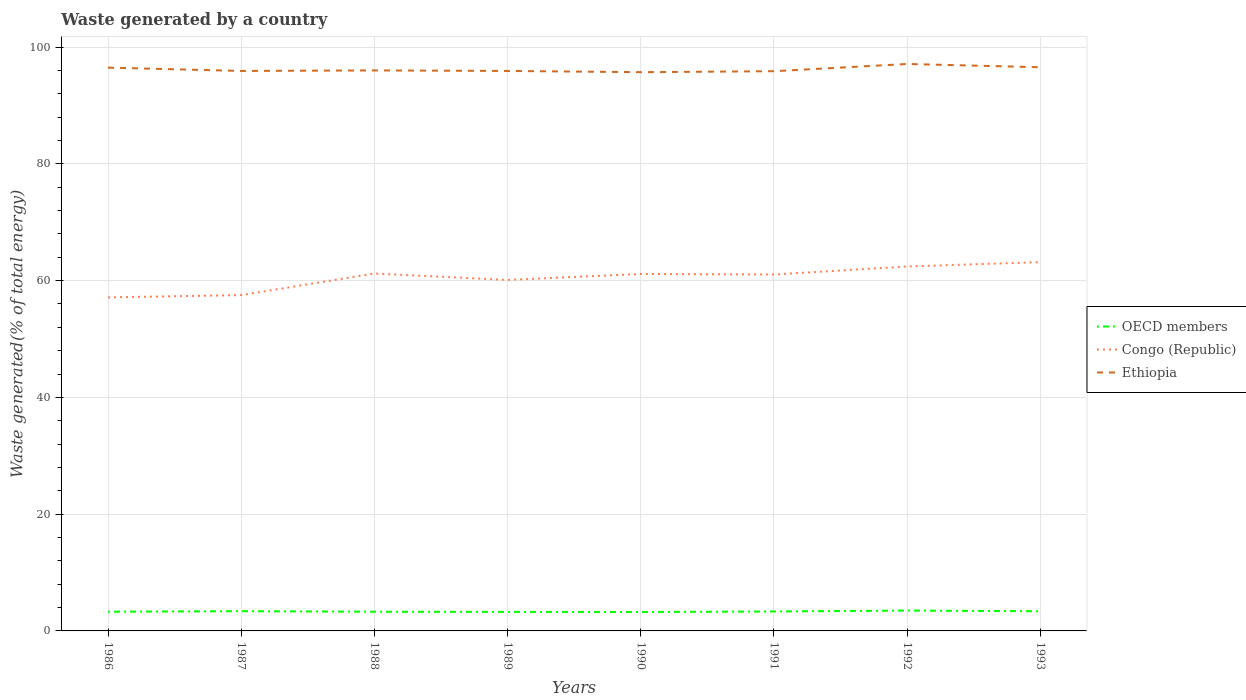Does the line corresponding to Ethiopia intersect with the line corresponding to OECD members?
Give a very brief answer. No. Across all years, what is the maximum total waste generated in Ethiopia?
Your answer should be very brief. 95.7. In which year was the total waste generated in Ethiopia maximum?
Make the answer very short. 1990. What is the total total waste generated in Ethiopia in the graph?
Your answer should be compact. 0. What is the difference between the highest and the second highest total waste generated in Ethiopia?
Your answer should be compact. 1.41. Are the values on the major ticks of Y-axis written in scientific E-notation?
Your answer should be compact. No. Does the graph contain any zero values?
Keep it short and to the point. No. Where does the legend appear in the graph?
Make the answer very short. Center right. How are the legend labels stacked?
Provide a short and direct response. Vertical. What is the title of the graph?
Ensure brevity in your answer.  Waste generated by a country. What is the label or title of the Y-axis?
Your response must be concise. Waste generated(% of total energy). What is the Waste generated(% of total energy) of OECD members in 1986?
Give a very brief answer. 3.29. What is the Waste generated(% of total energy) of Congo (Republic) in 1986?
Your response must be concise. 57.12. What is the Waste generated(% of total energy) in Ethiopia in 1986?
Keep it short and to the point. 96.48. What is the Waste generated(% of total energy) of OECD members in 1987?
Offer a terse response. 3.38. What is the Waste generated(% of total energy) in Congo (Republic) in 1987?
Offer a terse response. 57.52. What is the Waste generated(% of total energy) in Ethiopia in 1987?
Your answer should be very brief. 95.91. What is the Waste generated(% of total energy) in OECD members in 1988?
Keep it short and to the point. 3.29. What is the Waste generated(% of total energy) of Congo (Republic) in 1988?
Ensure brevity in your answer.  61.21. What is the Waste generated(% of total energy) in Ethiopia in 1988?
Your answer should be very brief. 96. What is the Waste generated(% of total energy) in OECD members in 1989?
Keep it short and to the point. 3.26. What is the Waste generated(% of total energy) in Congo (Republic) in 1989?
Offer a very short reply. 60.11. What is the Waste generated(% of total energy) of Ethiopia in 1989?
Keep it short and to the point. 95.91. What is the Waste generated(% of total energy) in OECD members in 1990?
Provide a succinct answer. 3.25. What is the Waste generated(% of total energy) in Congo (Republic) in 1990?
Give a very brief answer. 61.14. What is the Waste generated(% of total energy) of Ethiopia in 1990?
Offer a terse response. 95.7. What is the Waste generated(% of total energy) of OECD members in 1991?
Offer a very short reply. 3.33. What is the Waste generated(% of total energy) in Congo (Republic) in 1991?
Your response must be concise. 61.04. What is the Waste generated(% of total energy) in Ethiopia in 1991?
Make the answer very short. 95.86. What is the Waste generated(% of total energy) of OECD members in 1992?
Offer a very short reply. 3.48. What is the Waste generated(% of total energy) in Congo (Republic) in 1992?
Provide a succinct answer. 62.42. What is the Waste generated(% of total energy) of Ethiopia in 1992?
Offer a very short reply. 97.1. What is the Waste generated(% of total energy) of OECD members in 1993?
Your answer should be very brief. 3.37. What is the Waste generated(% of total energy) of Congo (Republic) in 1993?
Give a very brief answer. 63.16. What is the Waste generated(% of total energy) of Ethiopia in 1993?
Keep it short and to the point. 96.54. Across all years, what is the maximum Waste generated(% of total energy) in OECD members?
Make the answer very short. 3.48. Across all years, what is the maximum Waste generated(% of total energy) in Congo (Republic)?
Your answer should be very brief. 63.16. Across all years, what is the maximum Waste generated(% of total energy) in Ethiopia?
Provide a short and direct response. 97.1. Across all years, what is the minimum Waste generated(% of total energy) of OECD members?
Give a very brief answer. 3.25. Across all years, what is the minimum Waste generated(% of total energy) in Congo (Republic)?
Ensure brevity in your answer.  57.12. Across all years, what is the minimum Waste generated(% of total energy) in Ethiopia?
Offer a very short reply. 95.7. What is the total Waste generated(% of total energy) in OECD members in the graph?
Your answer should be very brief. 26.66. What is the total Waste generated(% of total energy) in Congo (Republic) in the graph?
Keep it short and to the point. 483.74. What is the total Waste generated(% of total energy) of Ethiopia in the graph?
Offer a very short reply. 769.5. What is the difference between the Waste generated(% of total energy) in OECD members in 1986 and that in 1987?
Your answer should be compact. -0.09. What is the difference between the Waste generated(% of total energy) in Congo (Republic) in 1986 and that in 1987?
Your response must be concise. -0.4. What is the difference between the Waste generated(% of total energy) in Ethiopia in 1986 and that in 1987?
Provide a succinct answer. 0.57. What is the difference between the Waste generated(% of total energy) in OECD members in 1986 and that in 1988?
Your answer should be very brief. -0. What is the difference between the Waste generated(% of total energy) in Congo (Republic) in 1986 and that in 1988?
Provide a short and direct response. -4.09. What is the difference between the Waste generated(% of total energy) of Ethiopia in 1986 and that in 1988?
Your response must be concise. 0.48. What is the difference between the Waste generated(% of total energy) of OECD members in 1986 and that in 1989?
Offer a terse response. 0.03. What is the difference between the Waste generated(% of total energy) in Congo (Republic) in 1986 and that in 1989?
Offer a very short reply. -2.99. What is the difference between the Waste generated(% of total energy) of Ethiopia in 1986 and that in 1989?
Ensure brevity in your answer.  0.57. What is the difference between the Waste generated(% of total energy) in OECD members in 1986 and that in 1990?
Provide a succinct answer. 0.05. What is the difference between the Waste generated(% of total energy) in Congo (Republic) in 1986 and that in 1990?
Make the answer very short. -4.02. What is the difference between the Waste generated(% of total energy) of Ethiopia in 1986 and that in 1990?
Provide a short and direct response. 0.78. What is the difference between the Waste generated(% of total energy) in OECD members in 1986 and that in 1991?
Offer a very short reply. -0.04. What is the difference between the Waste generated(% of total energy) in Congo (Republic) in 1986 and that in 1991?
Provide a succinct answer. -3.92. What is the difference between the Waste generated(% of total energy) of Ethiopia in 1986 and that in 1991?
Offer a terse response. 0.62. What is the difference between the Waste generated(% of total energy) of OECD members in 1986 and that in 1992?
Your response must be concise. -0.19. What is the difference between the Waste generated(% of total energy) in Congo (Republic) in 1986 and that in 1992?
Make the answer very short. -5.29. What is the difference between the Waste generated(% of total energy) of Ethiopia in 1986 and that in 1992?
Make the answer very short. -0.62. What is the difference between the Waste generated(% of total energy) of OECD members in 1986 and that in 1993?
Your response must be concise. -0.08. What is the difference between the Waste generated(% of total energy) of Congo (Republic) in 1986 and that in 1993?
Give a very brief answer. -6.04. What is the difference between the Waste generated(% of total energy) of Ethiopia in 1986 and that in 1993?
Offer a terse response. -0.06. What is the difference between the Waste generated(% of total energy) of OECD members in 1987 and that in 1988?
Ensure brevity in your answer.  0.09. What is the difference between the Waste generated(% of total energy) in Congo (Republic) in 1987 and that in 1988?
Keep it short and to the point. -3.7. What is the difference between the Waste generated(% of total energy) of Ethiopia in 1987 and that in 1988?
Your response must be concise. -0.09. What is the difference between the Waste generated(% of total energy) in OECD members in 1987 and that in 1989?
Your answer should be very brief. 0.12. What is the difference between the Waste generated(% of total energy) of Congo (Republic) in 1987 and that in 1989?
Keep it short and to the point. -2.59. What is the difference between the Waste generated(% of total energy) of OECD members in 1987 and that in 1990?
Offer a very short reply. 0.13. What is the difference between the Waste generated(% of total energy) in Congo (Republic) in 1987 and that in 1990?
Keep it short and to the point. -3.62. What is the difference between the Waste generated(% of total energy) of Ethiopia in 1987 and that in 1990?
Your answer should be compact. 0.21. What is the difference between the Waste generated(% of total energy) in OECD members in 1987 and that in 1991?
Offer a very short reply. 0.05. What is the difference between the Waste generated(% of total energy) of Congo (Republic) in 1987 and that in 1991?
Offer a terse response. -3.52. What is the difference between the Waste generated(% of total energy) in Ethiopia in 1987 and that in 1991?
Offer a terse response. 0.05. What is the difference between the Waste generated(% of total energy) of OECD members in 1987 and that in 1992?
Your answer should be very brief. -0.11. What is the difference between the Waste generated(% of total energy) in Congo (Republic) in 1987 and that in 1992?
Your response must be concise. -4.9. What is the difference between the Waste generated(% of total energy) of Ethiopia in 1987 and that in 1992?
Your response must be concise. -1.19. What is the difference between the Waste generated(% of total energy) in OECD members in 1987 and that in 1993?
Your response must be concise. 0.01. What is the difference between the Waste generated(% of total energy) of Congo (Republic) in 1987 and that in 1993?
Provide a short and direct response. -5.65. What is the difference between the Waste generated(% of total energy) in Ethiopia in 1987 and that in 1993?
Offer a very short reply. -0.63. What is the difference between the Waste generated(% of total energy) of OECD members in 1988 and that in 1989?
Ensure brevity in your answer.  0.03. What is the difference between the Waste generated(% of total energy) in Congo (Republic) in 1988 and that in 1989?
Keep it short and to the point. 1.1. What is the difference between the Waste generated(% of total energy) in Ethiopia in 1988 and that in 1989?
Your answer should be compact. 0.09. What is the difference between the Waste generated(% of total energy) of OECD members in 1988 and that in 1990?
Your answer should be very brief. 0.05. What is the difference between the Waste generated(% of total energy) of Congo (Republic) in 1988 and that in 1990?
Offer a terse response. 0.07. What is the difference between the Waste generated(% of total energy) in Ethiopia in 1988 and that in 1990?
Offer a very short reply. 0.3. What is the difference between the Waste generated(% of total energy) of OECD members in 1988 and that in 1991?
Ensure brevity in your answer.  -0.04. What is the difference between the Waste generated(% of total energy) of Congo (Republic) in 1988 and that in 1991?
Give a very brief answer. 0.17. What is the difference between the Waste generated(% of total energy) of Ethiopia in 1988 and that in 1991?
Your answer should be very brief. 0.13. What is the difference between the Waste generated(% of total energy) of OECD members in 1988 and that in 1992?
Your answer should be compact. -0.19. What is the difference between the Waste generated(% of total energy) of Congo (Republic) in 1988 and that in 1992?
Your response must be concise. -1.2. What is the difference between the Waste generated(% of total energy) in Ethiopia in 1988 and that in 1992?
Provide a succinct answer. -1.1. What is the difference between the Waste generated(% of total energy) of OECD members in 1988 and that in 1993?
Your answer should be very brief. -0.08. What is the difference between the Waste generated(% of total energy) of Congo (Republic) in 1988 and that in 1993?
Your answer should be compact. -1.95. What is the difference between the Waste generated(% of total energy) of Ethiopia in 1988 and that in 1993?
Offer a very short reply. -0.54. What is the difference between the Waste generated(% of total energy) in OECD members in 1989 and that in 1990?
Give a very brief answer. 0.02. What is the difference between the Waste generated(% of total energy) in Congo (Republic) in 1989 and that in 1990?
Provide a short and direct response. -1.03. What is the difference between the Waste generated(% of total energy) of Ethiopia in 1989 and that in 1990?
Keep it short and to the point. 0.21. What is the difference between the Waste generated(% of total energy) in OECD members in 1989 and that in 1991?
Your answer should be compact. -0.07. What is the difference between the Waste generated(% of total energy) in Congo (Republic) in 1989 and that in 1991?
Provide a short and direct response. -0.93. What is the difference between the Waste generated(% of total energy) in Ethiopia in 1989 and that in 1991?
Provide a short and direct response. 0.04. What is the difference between the Waste generated(% of total energy) of OECD members in 1989 and that in 1992?
Provide a short and direct response. -0.22. What is the difference between the Waste generated(% of total energy) of Congo (Republic) in 1989 and that in 1992?
Give a very brief answer. -2.31. What is the difference between the Waste generated(% of total energy) of Ethiopia in 1989 and that in 1992?
Provide a succinct answer. -1.19. What is the difference between the Waste generated(% of total energy) of OECD members in 1989 and that in 1993?
Keep it short and to the point. -0.11. What is the difference between the Waste generated(% of total energy) of Congo (Republic) in 1989 and that in 1993?
Make the answer very short. -3.05. What is the difference between the Waste generated(% of total energy) in Ethiopia in 1989 and that in 1993?
Provide a short and direct response. -0.63. What is the difference between the Waste generated(% of total energy) of OECD members in 1990 and that in 1991?
Provide a short and direct response. -0.08. What is the difference between the Waste generated(% of total energy) in Congo (Republic) in 1990 and that in 1991?
Provide a short and direct response. 0.1. What is the difference between the Waste generated(% of total energy) of Ethiopia in 1990 and that in 1991?
Your answer should be very brief. -0.17. What is the difference between the Waste generated(% of total energy) in OECD members in 1990 and that in 1992?
Provide a short and direct response. -0.24. What is the difference between the Waste generated(% of total energy) of Congo (Republic) in 1990 and that in 1992?
Keep it short and to the point. -1.28. What is the difference between the Waste generated(% of total energy) in Ethiopia in 1990 and that in 1992?
Make the answer very short. -1.41. What is the difference between the Waste generated(% of total energy) of OECD members in 1990 and that in 1993?
Provide a succinct answer. -0.12. What is the difference between the Waste generated(% of total energy) of Congo (Republic) in 1990 and that in 1993?
Your response must be concise. -2.02. What is the difference between the Waste generated(% of total energy) in Ethiopia in 1990 and that in 1993?
Your response must be concise. -0.84. What is the difference between the Waste generated(% of total energy) of OECD members in 1991 and that in 1992?
Your answer should be very brief. -0.15. What is the difference between the Waste generated(% of total energy) of Congo (Republic) in 1991 and that in 1992?
Your answer should be very brief. -1.38. What is the difference between the Waste generated(% of total energy) in Ethiopia in 1991 and that in 1992?
Ensure brevity in your answer.  -1.24. What is the difference between the Waste generated(% of total energy) in OECD members in 1991 and that in 1993?
Provide a succinct answer. -0.04. What is the difference between the Waste generated(% of total energy) of Congo (Republic) in 1991 and that in 1993?
Ensure brevity in your answer.  -2.12. What is the difference between the Waste generated(% of total energy) of Ethiopia in 1991 and that in 1993?
Make the answer very short. -0.68. What is the difference between the Waste generated(% of total energy) of OECD members in 1992 and that in 1993?
Keep it short and to the point. 0.12. What is the difference between the Waste generated(% of total energy) in Congo (Republic) in 1992 and that in 1993?
Provide a short and direct response. -0.75. What is the difference between the Waste generated(% of total energy) in Ethiopia in 1992 and that in 1993?
Your answer should be compact. 0.56. What is the difference between the Waste generated(% of total energy) in OECD members in 1986 and the Waste generated(% of total energy) in Congo (Republic) in 1987?
Give a very brief answer. -54.23. What is the difference between the Waste generated(% of total energy) of OECD members in 1986 and the Waste generated(% of total energy) of Ethiopia in 1987?
Offer a terse response. -92.62. What is the difference between the Waste generated(% of total energy) of Congo (Republic) in 1986 and the Waste generated(% of total energy) of Ethiopia in 1987?
Provide a succinct answer. -38.79. What is the difference between the Waste generated(% of total energy) of OECD members in 1986 and the Waste generated(% of total energy) of Congo (Republic) in 1988?
Ensure brevity in your answer.  -57.92. What is the difference between the Waste generated(% of total energy) in OECD members in 1986 and the Waste generated(% of total energy) in Ethiopia in 1988?
Keep it short and to the point. -92.71. What is the difference between the Waste generated(% of total energy) of Congo (Republic) in 1986 and the Waste generated(% of total energy) of Ethiopia in 1988?
Ensure brevity in your answer.  -38.88. What is the difference between the Waste generated(% of total energy) of OECD members in 1986 and the Waste generated(% of total energy) of Congo (Republic) in 1989?
Offer a terse response. -56.82. What is the difference between the Waste generated(% of total energy) of OECD members in 1986 and the Waste generated(% of total energy) of Ethiopia in 1989?
Offer a terse response. -92.62. What is the difference between the Waste generated(% of total energy) of Congo (Republic) in 1986 and the Waste generated(% of total energy) of Ethiopia in 1989?
Give a very brief answer. -38.79. What is the difference between the Waste generated(% of total energy) of OECD members in 1986 and the Waste generated(% of total energy) of Congo (Republic) in 1990?
Offer a very short reply. -57.85. What is the difference between the Waste generated(% of total energy) of OECD members in 1986 and the Waste generated(% of total energy) of Ethiopia in 1990?
Your response must be concise. -92.4. What is the difference between the Waste generated(% of total energy) in Congo (Republic) in 1986 and the Waste generated(% of total energy) in Ethiopia in 1990?
Your answer should be compact. -38.57. What is the difference between the Waste generated(% of total energy) in OECD members in 1986 and the Waste generated(% of total energy) in Congo (Republic) in 1991?
Keep it short and to the point. -57.75. What is the difference between the Waste generated(% of total energy) of OECD members in 1986 and the Waste generated(% of total energy) of Ethiopia in 1991?
Your response must be concise. -92.57. What is the difference between the Waste generated(% of total energy) in Congo (Republic) in 1986 and the Waste generated(% of total energy) in Ethiopia in 1991?
Provide a succinct answer. -38.74. What is the difference between the Waste generated(% of total energy) of OECD members in 1986 and the Waste generated(% of total energy) of Congo (Republic) in 1992?
Provide a short and direct response. -59.13. What is the difference between the Waste generated(% of total energy) in OECD members in 1986 and the Waste generated(% of total energy) in Ethiopia in 1992?
Provide a succinct answer. -93.81. What is the difference between the Waste generated(% of total energy) of Congo (Republic) in 1986 and the Waste generated(% of total energy) of Ethiopia in 1992?
Provide a succinct answer. -39.98. What is the difference between the Waste generated(% of total energy) of OECD members in 1986 and the Waste generated(% of total energy) of Congo (Republic) in 1993?
Provide a short and direct response. -59.87. What is the difference between the Waste generated(% of total energy) in OECD members in 1986 and the Waste generated(% of total energy) in Ethiopia in 1993?
Your answer should be very brief. -93.25. What is the difference between the Waste generated(% of total energy) of Congo (Republic) in 1986 and the Waste generated(% of total energy) of Ethiopia in 1993?
Ensure brevity in your answer.  -39.42. What is the difference between the Waste generated(% of total energy) of OECD members in 1987 and the Waste generated(% of total energy) of Congo (Republic) in 1988?
Your response must be concise. -57.84. What is the difference between the Waste generated(% of total energy) in OECD members in 1987 and the Waste generated(% of total energy) in Ethiopia in 1988?
Keep it short and to the point. -92.62. What is the difference between the Waste generated(% of total energy) in Congo (Republic) in 1987 and the Waste generated(% of total energy) in Ethiopia in 1988?
Offer a very short reply. -38.48. What is the difference between the Waste generated(% of total energy) in OECD members in 1987 and the Waste generated(% of total energy) in Congo (Republic) in 1989?
Make the answer very short. -56.73. What is the difference between the Waste generated(% of total energy) in OECD members in 1987 and the Waste generated(% of total energy) in Ethiopia in 1989?
Give a very brief answer. -92.53. What is the difference between the Waste generated(% of total energy) in Congo (Republic) in 1987 and the Waste generated(% of total energy) in Ethiopia in 1989?
Provide a succinct answer. -38.39. What is the difference between the Waste generated(% of total energy) of OECD members in 1987 and the Waste generated(% of total energy) of Congo (Republic) in 1990?
Keep it short and to the point. -57.76. What is the difference between the Waste generated(% of total energy) of OECD members in 1987 and the Waste generated(% of total energy) of Ethiopia in 1990?
Give a very brief answer. -92.32. What is the difference between the Waste generated(% of total energy) of Congo (Republic) in 1987 and the Waste generated(% of total energy) of Ethiopia in 1990?
Your response must be concise. -38.18. What is the difference between the Waste generated(% of total energy) in OECD members in 1987 and the Waste generated(% of total energy) in Congo (Republic) in 1991?
Provide a short and direct response. -57.66. What is the difference between the Waste generated(% of total energy) of OECD members in 1987 and the Waste generated(% of total energy) of Ethiopia in 1991?
Your answer should be very brief. -92.48. What is the difference between the Waste generated(% of total energy) of Congo (Republic) in 1987 and the Waste generated(% of total energy) of Ethiopia in 1991?
Give a very brief answer. -38.35. What is the difference between the Waste generated(% of total energy) of OECD members in 1987 and the Waste generated(% of total energy) of Congo (Republic) in 1992?
Your response must be concise. -59.04. What is the difference between the Waste generated(% of total energy) in OECD members in 1987 and the Waste generated(% of total energy) in Ethiopia in 1992?
Provide a short and direct response. -93.72. What is the difference between the Waste generated(% of total energy) in Congo (Republic) in 1987 and the Waste generated(% of total energy) in Ethiopia in 1992?
Provide a succinct answer. -39.58. What is the difference between the Waste generated(% of total energy) of OECD members in 1987 and the Waste generated(% of total energy) of Congo (Republic) in 1993?
Offer a terse response. -59.79. What is the difference between the Waste generated(% of total energy) of OECD members in 1987 and the Waste generated(% of total energy) of Ethiopia in 1993?
Offer a very short reply. -93.16. What is the difference between the Waste generated(% of total energy) of Congo (Republic) in 1987 and the Waste generated(% of total energy) of Ethiopia in 1993?
Your answer should be compact. -39.02. What is the difference between the Waste generated(% of total energy) of OECD members in 1988 and the Waste generated(% of total energy) of Congo (Republic) in 1989?
Make the answer very short. -56.82. What is the difference between the Waste generated(% of total energy) of OECD members in 1988 and the Waste generated(% of total energy) of Ethiopia in 1989?
Keep it short and to the point. -92.62. What is the difference between the Waste generated(% of total energy) in Congo (Republic) in 1988 and the Waste generated(% of total energy) in Ethiopia in 1989?
Your response must be concise. -34.69. What is the difference between the Waste generated(% of total energy) of OECD members in 1988 and the Waste generated(% of total energy) of Congo (Republic) in 1990?
Offer a very short reply. -57.85. What is the difference between the Waste generated(% of total energy) in OECD members in 1988 and the Waste generated(% of total energy) in Ethiopia in 1990?
Your response must be concise. -92.4. What is the difference between the Waste generated(% of total energy) in Congo (Republic) in 1988 and the Waste generated(% of total energy) in Ethiopia in 1990?
Provide a succinct answer. -34.48. What is the difference between the Waste generated(% of total energy) in OECD members in 1988 and the Waste generated(% of total energy) in Congo (Republic) in 1991?
Make the answer very short. -57.75. What is the difference between the Waste generated(% of total energy) of OECD members in 1988 and the Waste generated(% of total energy) of Ethiopia in 1991?
Provide a short and direct response. -92.57. What is the difference between the Waste generated(% of total energy) in Congo (Republic) in 1988 and the Waste generated(% of total energy) in Ethiopia in 1991?
Offer a very short reply. -34.65. What is the difference between the Waste generated(% of total energy) in OECD members in 1988 and the Waste generated(% of total energy) in Congo (Republic) in 1992?
Your answer should be very brief. -59.12. What is the difference between the Waste generated(% of total energy) in OECD members in 1988 and the Waste generated(% of total energy) in Ethiopia in 1992?
Provide a succinct answer. -93.81. What is the difference between the Waste generated(% of total energy) in Congo (Republic) in 1988 and the Waste generated(% of total energy) in Ethiopia in 1992?
Offer a terse response. -35.89. What is the difference between the Waste generated(% of total energy) of OECD members in 1988 and the Waste generated(% of total energy) of Congo (Republic) in 1993?
Keep it short and to the point. -59.87. What is the difference between the Waste generated(% of total energy) of OECD members in 1988 and the Waste generated(% of total energy) of Ethiopia in 1993?
Offer a terse response. -93.25. What is the difference between the Waste generated(% of total energy) of Congo (Republic) in 1988 and the Waste generated(% of total energy) of Ethiopia in 1993?
Make the answer very short. -35.33. What is the difference between the Waste generated(% of total energy) of OECD members in 1989 and the Waste generated(% of total energy) of Congo (Republic) in 1990?
Offer a terse response. -57.88. What is the difference between the Waste generated(% of total energy) of OECD members in 1989 and the Waste generated(% of total energy) of Ethiopia in 1990?
Provide a short and direct response. -92.44. What is the difference between the Waste generated(% of total energy) of Congo (Republic) in 1989 and the Waste generated(% of total energy) of Ethiopia in 1990?
Offer a very short reply. -35.59. What is the difference between the Waste generated(% of total energy) of OECD members in 1989 and the Waste generated(% of total energy) of Congo (Republic) in 1991?
Offer a terse response. -57.78. What is the difference between the Waste generated(% of total energy) of OECD members in 1989 and the Waste generated(% of total energy) of Ethiopia in 1991?
Provide a short and direct response. -92.6. What is the difference between the Waste generated(% of total energy) in Congo (Republic) in 1989 and the Waste generated(% of total energy) in Ethiopia in 1991?
Give a very brief answer. -35.75. What is the difference between the Waste generated(% of total energy) in OECD members in 1989 and the Waste generated(% of total energy) in Congo (Republic) in 1992?
Your response must be concise. -59.16. What is the difference between the Waste generated(% of total energy) in OECD members in 1989 and the Waste generated(% of total energy) in Ethiopia in 1992?
Offer a very short reply. -93.84. What is the difference between the Waste generated(% of total energy) of Congo (Republic) in 1989 and the Waste generated(% of total energy) of Ethiopia in 1992?
Keep it short and to the point. -36.99. What is the difference between the Waste generated(% of total energy) in OECD members in 1989 and the Waste generated(% of total energy) in Congo (Republic) in 1993?
Offer a very short reply. -59.9. What is the difference between the Waste generated(% of total energy) of OECD members in 1989 and the Waste generated(% of total energy) of Ethiopia in 1993?
Ensure brevity in your answer.  -93.28. What is the difference between the Waste generated(% of total energy) in Congo (Republic) in 1989 and the Waste generated(% of total energy) in Ethiopia in 1993?
Offer a terse response. -36.43. What is the difference between the Waste generated(% of total energy) in OECD members in 1990 and the Waste generated(% of total energy) in Congo (Republic) in 1991?
Keep it short and to the point. -57.8. What is the difference between the Waste generated(% of total energy) of OECD members in 1990 and the Waste generated(% of total energy) of Ethiopia in 1991?
Your answer should be very brief. -92.62. What is the difference between the Waste generated(% of total energy) in Congo (Republic) in 1990 and the Waste generated(% of total energy) in Ethiopia in 1991?
Give a very brief answer. -34.72. What is the difference between the Waste generated(% of total energy) in OECD members in 1990 and the Waste generated(% of total energy) in Congo (Republic) in 1992?
Offer a terse response. -59.17. What is the difference between the Waste generated(% of total energy) in OECD members in 1990 and the Waste generated(% of total energy) in Ethiopia in 1992?
Ensure brevity in your answer.  -93.86. What is the difference between the Waste generated(% of total energy) in Congo (Republic) in 1990 and the Waste generated(% of total energy) in Ethiopia in 1992?
Give a very brief answer. -35.96. What is the difference between the Waste generated(% of total energy) in OECD members in 1990 and the Waste generated(% of total energy) in Congo (Republic) in 1993?
Provide a succinct answer. -59.92. What is the difference between the Waste generated(% of total energy) in OECD members in 1990 and the Waste generated(% of total energy) in Ethiopia in 1993?
Make the answer very short. -93.29. What is the difference between the Waste generated(% of total energy) of Congo (Republic) in 1990 and the Waste generated(% of total energy) of Ethiopia in 1993?
Ensure brevity in your answer.  -35.4. What is the difference between the Waste generated(% of total energy) in OECD members in 1991 and the Waste generated(% of total energy) in Congo (Republic) in 1992?
Your answer should be very brief. -59.09. What is the difference between the Waste generated(% of total energy) in OECD members in 1991 and the Waste generated(% of total energy) in Ethiopia in 1992?
Offer a terse response. -93.77. What is the difference between the Waste generated(% of total energy) in Congo (Republic) in 1991 and the Waste generated(% of total energy) in Ethiopia in 1992?
Offer a very short reply. -36.06. What is the difference between the Waste generated(% of total energy) of OECD members in 1991 and the Waste generated(% of total energy) of Congo (Republic) in 1993?
Keep it short and to the point. -59.83. What is the difference between the Waste generated(% of total energy) in OECD members in 1991 and the Waste generated(% of total energy) in Ethiopia in 1993?
Your answer should be compact. -93.21. What is the difference between the Waste generated(% of total energy) of Congo (Republic) in 1991 and the Waste generated(% of total energy) of Ethiopia in 1993?
Your response must be concise. -35.5. What is the difference between the Waste generated(% of total energy) in OECD members in 1992 and the Waste generated(% of total energy) in Congo (Republic) in 1993?
Your answer should be compact. -59.68. What is the difference between the Waste generated(% of total energy) in OECD members in 1992 and the Waste generated(% of total energy) in Ethiopia in 1993?
Keep it short and to the point. -93.06. What is the difference between the Waste generated(% of total energy) in Congo (Republic) in 1992 and the Waste generated(% of total energy) in Ethiopia in 1993?
Your response must be concise. -34.12. What is the average Waste generated(% of total energy) in OECD members per year?
Provide a short and direct response. 3.33. What is the average Waste generated(% of total energy) in Congo (Republic) per year?
Keep it short and to the point. 60.47. What is the average Waste generated(% of total energy) of Ethiopia per year?
Offer a very short reply. 96.19. In the year 1986, what is the difference between the Waste generated(% of total energy) of OECD members and Waste generated(% of total energy) of Congo (Republic)?
Offer a terse response. -53.83. In the year 1986, what is the difference between the Waste generated(% of total energy) in OECD members and Waste generated(% of total energy) in Ethiopia?
Give a very brief answer. -93.19. In the year 1986, what is the difference between the Waste generated(% of total energy) in Congo (Republic) and Waste generated(% of total energy) in Ethiopia?
Your answer should be compact. -39.36. In the year 1987, what is the difference between the Waste generated(% of total energy) of OECD members and Waste generated(% of total energy) of Congo (Republic)?
Offer a very short reply. -54.14. In the year 1987, what is the difference between the Waste generated(% of total energy) in OECD members and Waste generated(% of total energy) in Ethiopia?
Give a very brief answer. -92.53. In the year 1987, what is the difference between the Waste generated(% of total energy) in Congo (Republic) and Waste generated(% of total energy) in Ethiopia?
Your response must be concise. -38.39. In the year 1988, what is the difference between the Waste generated(% of total energy) in OECD members and Waste generated(% of total energy) in Congo (Republic)?
Your response must be concise. -57.92. In the year 1988, what is the difference between the Waste generated(% of total energy) in OECD members and Waste generated(% of total energy) in Ethiopia?
Ensure brevity in your answer.  -92.71. In the year 1988, what is the difference between the Waste generated(% of total energy) of Congo (Republic) and Waste generated(% of total energy) of Ethiopia?
Your answer should be compact. -34.78. In the year 1989, what is the difference between the Waste generated(% of total energy) in OECD members and Waste generated(% of total energy) in Congo (Republic)?
Offer a terse response. -56.85. In the year 1989, what is the difference between the Waste generated(% of total energy) of OECD members and Waste generated(% of total energy) of Ethiopia?
Your answer should be very brief. -92.65. In the year 1989, what is the difference between the Waste generated(% of total energy) of Congo (Republic) and Waste generated(% of total energy) of Ethiopia?
Give a very brief answer. -35.8. In the year 1990, what is the difference between the Waste generated(% of total energy) of OECD members and Waste generated(% of total energy) of Congo (Republic)?
Keep it short and to the point. -57.9. In the year 1990, what is the difference between the Waste generated(% of total energy) of OECD members and Waste generated(% of total energy) of Ethiopia?
Your answer should be compact. -92.45. In the year 1990, what is the difference between the Waste generated(% of total energy) in Congo (Republic) and Waste generated(% of total energy) in Ethiopia?
Make the answer very short. -34.56. In the year 1991, what is the difference between the Waste generated(% of total energy) of OECD members and Waste generated(% of total energy) of Congo (Republic)?
Give a very brief answer. -57.71. In the year 1991, what is the difference between the Waste generated(% of total energy) of OECD members and Waste generated(% of total energy) of Ethiopia?
Your answer should be very brief. -92.53. In the year 1991, what is the difference between the Waste generated(% of total energy) in Congo (Republic) and Waste generated(% of total energy) in Ethiopia?
Your response must be concise. -34.82. In the year 1992, what is the difference between the Waste generated(% of total energy) in OECD members and Waste generated(% of total energy) in Congo (Republic)?
Provide a succinct answer. -58.93. In the year 1992, what is the difference between the Waste generated(% of total energy) of OECD members and Waste generated(% of total energy) of Ethiopia?
Your response must be concise. -93.62. In the year 1992, what is the difference between the Waste generated(% of total energy) of Congo (Republic) and Waste generated(% of total energy) of Ethiopia?
Provide a short and direct response. -34.68. In the year 1993, what is the difference between the Waste generated(% of total energy) of OECD members and Waste generated(% of total energy) of Congo (Republic)?
Give a very brief answer. -59.8. In the year 1993, what is the difference between the Waste generated(% of total energy) of OECD members and Waste generated(% of total energy) of Ethiopia?
Provide a short and direct response. -93.17. In the year 1993, what is the difference between the Waste generated(% of total energy) in Congo (Republic) and Waste generated(% of total energy) in Ethiopia?
Offer a very short reply. -33.38. What is the ratio of the Waste generated(% of total energy) in OECD members in 1986 to that in 1987?
Make the answer very short. 0.97. What is the ratio of the Waste generated(% of total energy) of Congo (Republic) in 1986 to that in 1988?
Make the answer very short. 0.93. What is the ratio of the Waste generated(% of total energy) in Ethiopia in 1986 to that in 1988?
Your answer should be compact. 1. What is the ratio of the Waste generated(% of total energy) in OECD members in 1986 to that in 1989?
Provide a succinct answer. 1.01. What is the ratio of the Waste generated(% of total energy) in Congo (Republic) in 1986 to that in 1989?
Your response must be concise. 0.95. What is the ratio of the Waste generated(% of total energy) in Ethiopia in 1986 to that in 1989?
Provide a short and direct response. 1.01. What is the ratio of the Waste generated(% of total energy) in OECD members in 1986 to that in 1990?
Your answer should be compact. 1.01. What is the ratio of the Waste generated(% of total energy) in Congo (Republic) in 1986 to that in 1990?
Offer a terse response. 0.93. What is the ratio of the Waste generated(% of total energy) in Ethiopia in 1986 to that in 1990?
Make the answer very short. 1.01. What is the ratio of the Waste generated(% of total energy) of OECD members in 1986 to that in 1991?
Provide a short and direct response. 0.99. What is the ratio of the Waste generated(% of total energy) of Congo (Republic) in 1986 to that in 1991?
Keep it short and to the point. 0.94. What is the ratio of the Waste generated(% of total energy) in Ethiopia in 1986 to that in 1991?
Your answer should be compact. 1.01. What is the ratio of the Waste generated(% of total energy) of OECD members in 1986 to that in 1992?
Keep it short and to the point. 0.94. What is the ratio of the Waste generated(% of total energy) of Congo (Republic) in 1986 to that in 1992?
Your answer should be very brief. 0.92. What is the ratio of the Waste generated(% of total energy) of Ethiopia in 1986 to that in 1992?
Your answer should be very brief. 0.99. What is the ratio of the Waste generated(% of total energy) in OECD members in 1986 to that in 1993?
Your answer should be compact. 0.98. What is the ratio of the Waste generated(% of total energy) in Congo (Republic) in 1986 to that in 1993?
Give a very brief answer. 0.9. What is the ratio of the Waste generated(% of total energy) of Congo (Republic) in 1987 to that in 1988?
Offer a terse response. 0.94. What is the ratio of the Waste generated(% of total energy) of OECD members in 1987 to that in 1989?
Provide a short and direct response. 1.04. What is the ratio of the Waste generated(% of total energy) of Congo (Republic) in 1987 to that in 1989?
Make the answer very short. 0.96. What is the ratio of the Waste generated(% of total energy) in Ethiopia in 1987 to that in 1989?
Your answer should be compact. 1. What is the ratio of the Waste generated(% of total energy) of OECD members in 1987 to that in 1990?
Offer a terse response. 1.04. What is the ratio of the Waste generated(% of total energy) in Congo (Republic) in 1987 to that in 1990?
Keep it short and to the point. 0.94. What is the ratio of the Waste generated(% of total energy) of Ethiopia in 1987 to that in 1990?
Keep it short and to the point. 1. What is the ratio of the Waste generated(% of total energy) in OECD members in 1987 to that in 1991?
Provide a succinct answer. 1.01. What is the ratio of the Waste generated(% of total energy) in Congo (Republic) in 1987 to that in 1991?
Offer a very short reply. 0.94. What is the ratio of the Waste generated(% of total energy) in Ethiopia in 1987 to that in 1991?
Make the answer very short. 1. What is the ratio of the Waste generated(% of total energy) in OECD members in 1987 to that in 1992?
Your answer should be compact. 0.97. What is the ratio of the Waste generated(% of total energy) of Congo (Republic) in 1987 to that in 1992?
Ensure brevity in your answer.  0.92. What is the ratio of the Waste generated(% of total energy) in OECD members in 1987 to that in 1993?
Keep it short and to the point. 1. What is the ratio of the Waste generated(% of total energy) in Congo (Republic) in 1987 to that in 1993?
Offer a very short reply. 0.91. What is the ratio of the Waste generated(% of total energy) of OECD members in 1988 to that in 1989?
Offer a very short reply. 1.01. What is the ratio of the Waste generated(% of total energy) of Congo (Republic) in 1988 to that in 1989?
Provide a short and direct response. 1.02. What is the ratio of the Waste generated(% of total energy) of Ethiopia in 1988 to that in 1989?
Your answer should be very brief. 1. What is the ratio of the Waste generated(% of total energy) of OECD members in 1988 to that in 1990?
Offer a very short reply. 1.01. What is the ratio of the Waste generated(% of total energy) in Ethiopia in 1988 to that in 1990?
Offer a terse response. 1. What is the ratio of the Waste generated(% of total energy) of OECD members in 1988 to that in 1991?
Ensure brevity in your answer.  0.99. What is the ratio of the Waste generated(% of total energy) of OECD members in 1988 to that in 1992?
Make the answer very short. 0.95. What is the ratio of the Waste generated(% of total energy) in Congo (Republic) in 1988 to that in 1992?
Provide a short and direct response. 0.98. What is the ratio of the Waste generated(% of total energy) of Ethiopia in 1988 to that in 1992?
Your answer should be very brief. 0.99. What is the ratio of the Waste generated(% of total energy) of OECD members in 1988 to that in 1993?
Your response must be concise. 0.98. What is the ratio of the Waste generated(% of total energy) of Congo (Republic) in 1988 to that in 1993?
Offer a terse response. 0.97. What is the ratio of the Waste generated(% of total energy) in OECD members in 1989 to that in 1990?
Offer a terse response. 1. What is the ratio of the Waste generated(% of total energy) of Congo (Republic) in 1989 to that in 1990?
Your answer should be compact. 0.98. What is the ratio of the Waste generated(% of total energy) of OECD members in 1989 to that in 1991?
Ensure brevity in your answer.  0.98. What is the ratio of the Waste generated(% of total energy) in Congo (Republic) in 1989 to that in 1991?
Your answer should be very brief. 0.98. What is the ratio of the Waste generated(% of total energy) of OECD members in 1989 to that in 1992?
Give a very brief answer. 0.94. What is the ratio of the Waste generated(% of total energy) in Ethiopia in 1989 to that in 1992?
Make the answer very short. 0.99. What is the ratio of the Waste generated(% of total energy) in OECD members in 1989 to that in 1993?
Ensure brevity in your answer.  0.97. What is the ratio of the Waste generated(% of total energy) in Congo (Republic) in 1989 to that in 1993?
Offer a very short reply. 0.95. What is the ratio of the Waste generated(% of total energy) of Ethiopia in 1989 to that in 1993?
Provide a succinct answer. 0.99. What is the ratio of the Waste generated(% of total energy) in OECD members in 1990 to that in 1991?
Your answer should be compact. 0.97. What is the ratio of the Waste generated(% of total energy) of OECD members in 1990 to that in 1992?
Make the answer very short. 0.93. What is the ratio of the Waste generated(% of total energy) of Congo (Republic) in 1990 to that in 1992?
Ensure brevity in your answer.  0.98. What is the ratio of the Waste generated(% of total energy) of Ethiopia in 1990 to that in 1992?
Keep it short and to the point. 0.99. What is the ratio of the Waste generated(% of total energy) of OECD members in 1990 to that in 1993?
Keep it short and to the point. 0.96. What is the ratio of the Waste generated(% of total energy) in Congo (Republic) in 1990 to that in 1993?
Your answer should be very brief. 0.97. What is the ratio of the Waste generated(% of total energy) of Ethiopia in 1990 to that in 1993?
Your answer should be very brief. 0.99. What is the ratio of the Waste generated(% of total energy) in OECD members in 1991 to that in 1992?
Make the answer very short. 0.96. What is the ratio of the Waste generated(% of total energy) of Congo (Republic) in 1991 to that in 1992?
Keep it short and to the point. 0.98. What is the ratio of the Waste generated(% of total energy) in Ethiopia in 1991 to that in 1992?
Offer a terse response. 0.99. What is the ratio of the Waste generated(% of total energy) of Congo (Republic) in 1991 to that in 1993?
Keep it short and to the point. 0.97. What is the ratio of the Waste generated(% of total energy) in Ethiopia in 1991 to that in 1993?
Offer a very short reply. 0.99. What is the ratio of the Waste generated(% of total energy) of OECD members in 1992 to that in 1993?
Provide a short and direct response. 1.03. What is the ratio of the Waste generated(% of total energy) of Congo (Republic) in 1992 to that in 1993?
Your answer should be compact. 0.99. What is the ratio of the Waste generated(% of total energy) of Ethiopia in 1992 to that in 1993?
Keep it short and to the point. 1.01. What is the difference between the highest and the second highest Waste generated(% of total energy) in OECD members?
Offer a terse response. 0.11. What is the difference between the highest and the second highest Waste generated(% of total energy) in Congo (Republic)?
Make the answer very short. 0.75. What is the difference between the highest and the second highest Waste generated(% of total energy) of Ethiopia?
Your answer should be very brief. 0.56. What is the difference between the highest and the lowest Waste generated(% of total energy) of OECD members?
Your answer should be very brief. 0.24. What is the difference between the highest and the lowest Waste generated(% of total energy) of Congo (Republic)?
Your response must be concise. 6.04. What is the difference between the highest and the lowest Waste generated(% of total energy) of Ethiopia?
Ensure brevity in your answer.  1.41. 